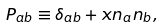Convert formula to latex. <formula><loc_0><loc_0><loc_500><loc_500>P _ { a b } \equiv \delta _ { a b } + x n _ { a } n _ { b } ,</formula> 